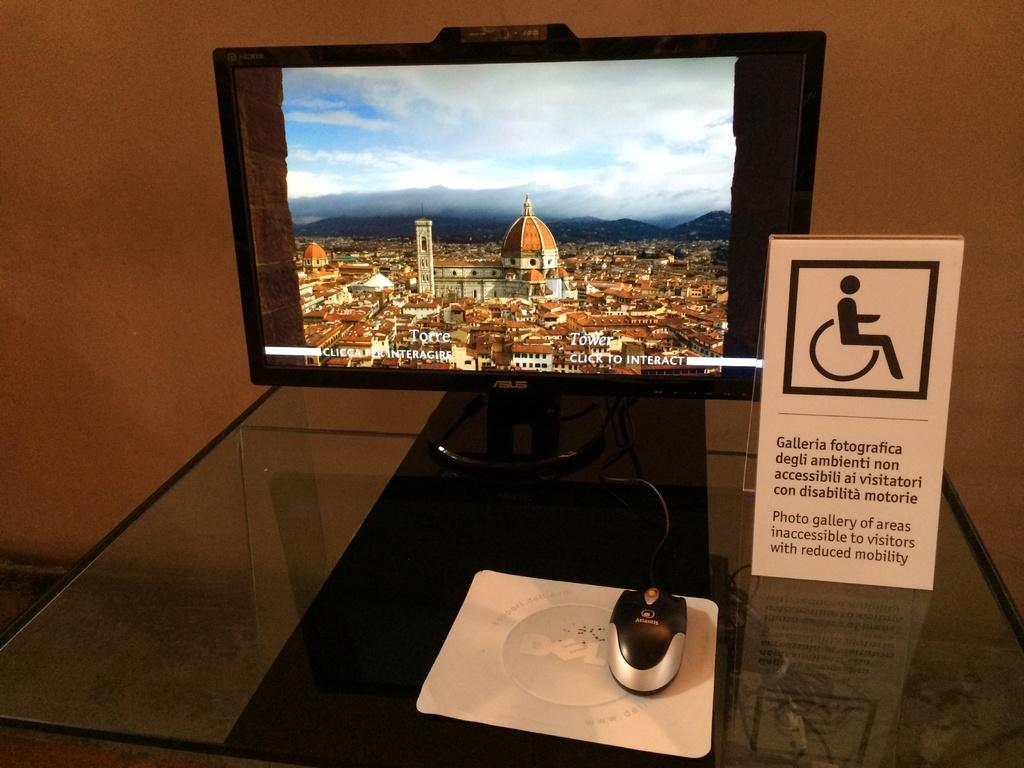<image>
Render a clear and concise summary of the photo. An Asus computer monitor next to a sign with a handicap icon on it. 